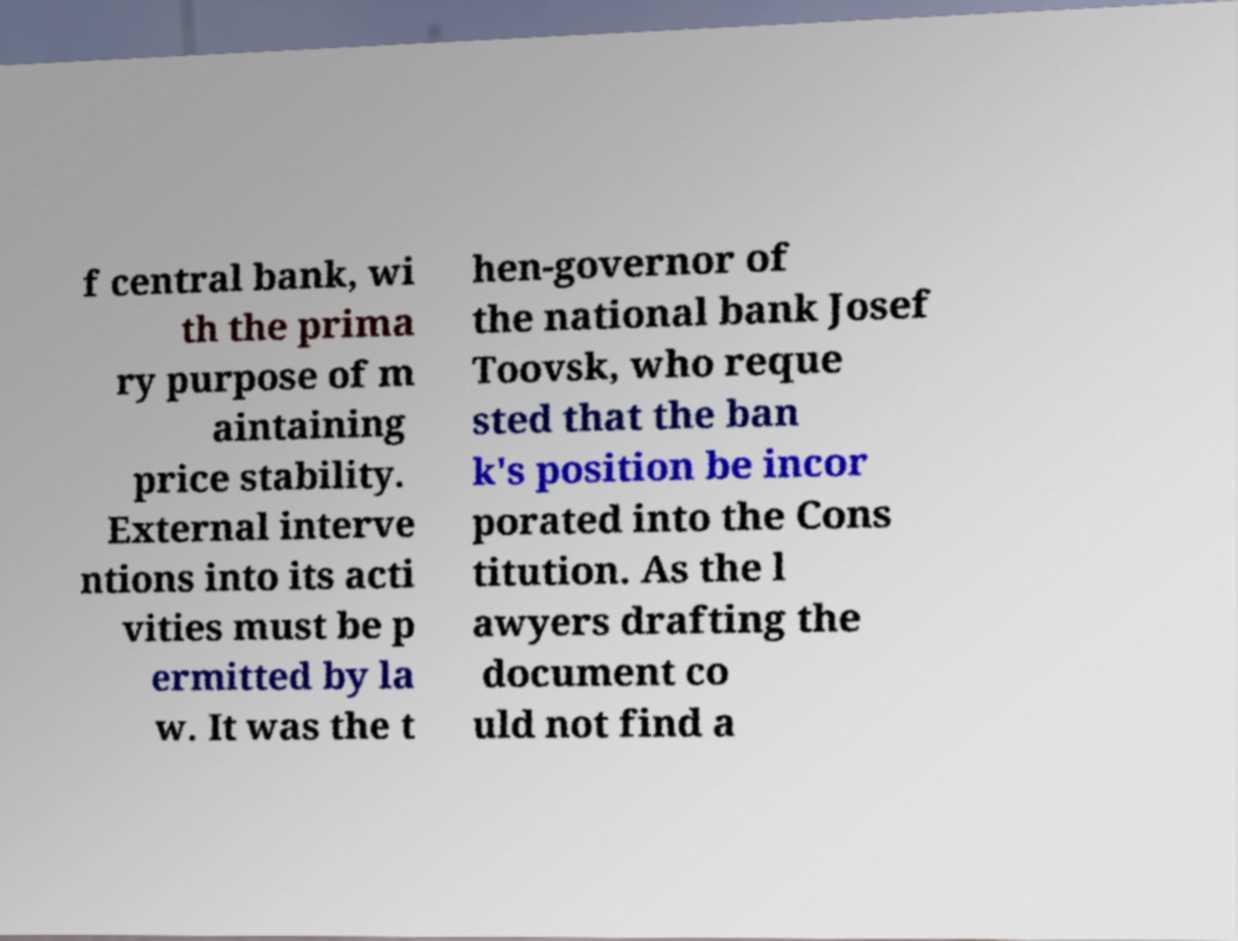What messages or text are displayed in this image? I need them in a readable, typed format. f central bank, wi th the prima ry purpose of m aintaining price stability. External interve ntions into its acti vities must be p ermitted by la w. It was the t hen-governor of the national bank Josef Toovsk, who reque sted that the ban k's position be incor porated into the Cons titution. As the l awyers drafting the document co uld not find a 